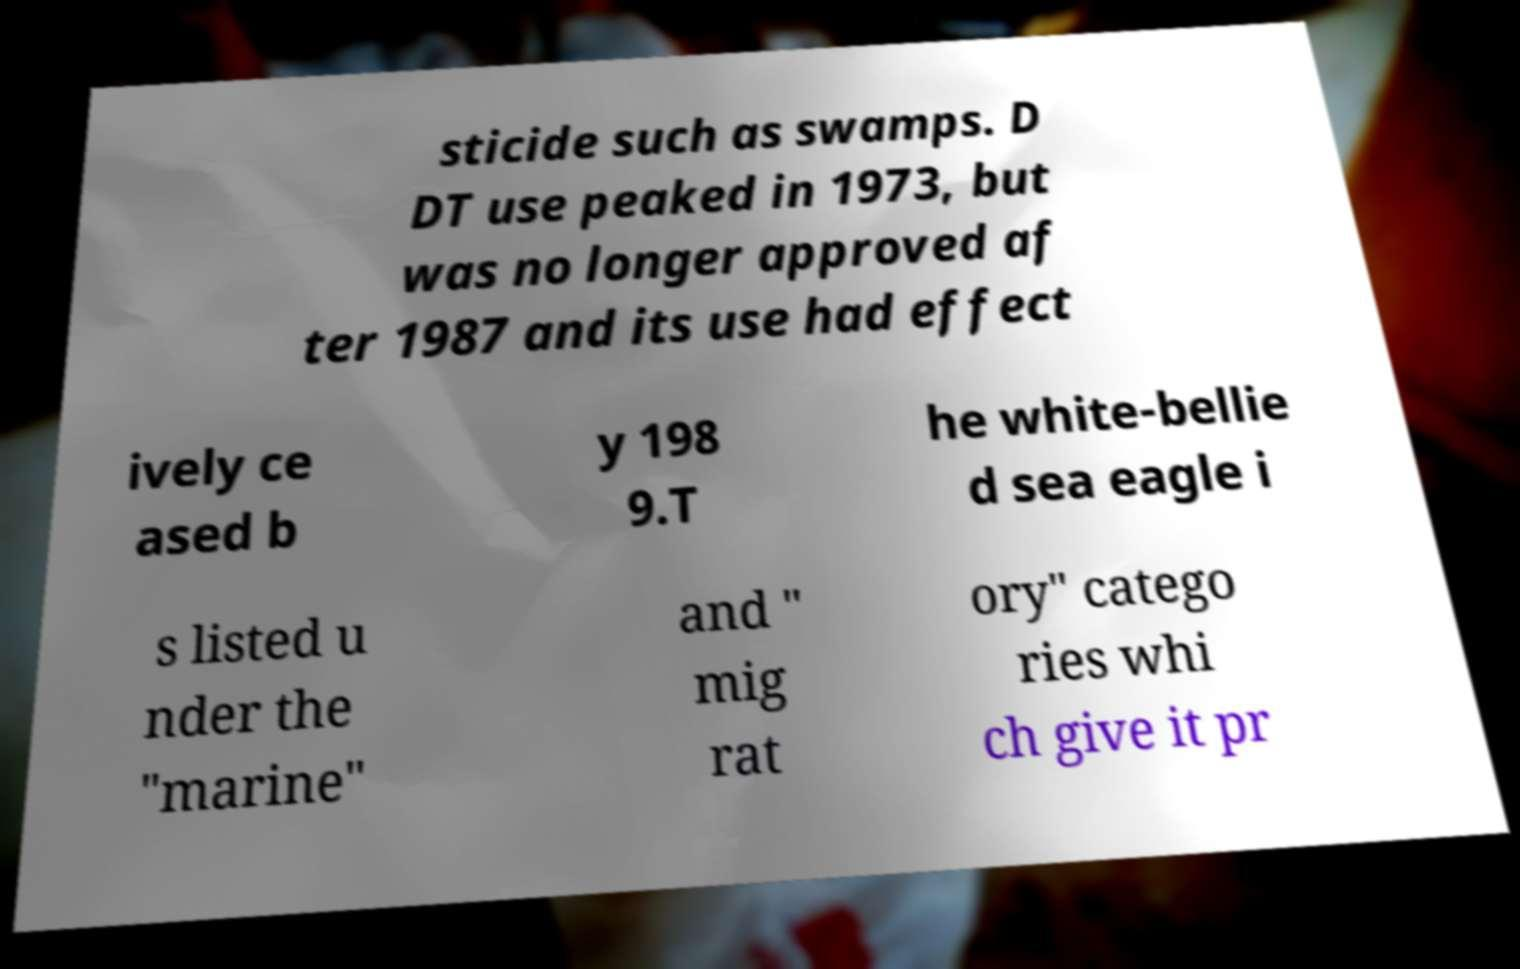I need the written content from this picture converted into text. Can you do that? sticide such as swamps. D DT use peaked in 1973, but was no longer approved af ter 1987 and its use had effect ively ce ased b y 198 9.T he white-bellie d sea eagle i s listed u nder the "marine" and " mig rat ory" catego ries whi ch give it pr 